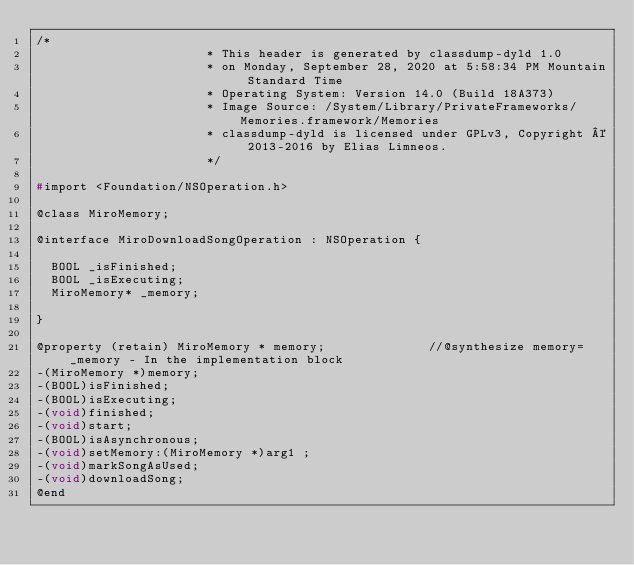<code> <loc_0><loc_0><loc_500><loc_500><_C_>/*
                       * This header is generated by classdump-dyld 1.0
                       * on Monday, September 28, 2020 at 5:58:34 PM Mountain Standard Time
                       * Operating System: Version 14.0 (Build 18A373)
                       * Image Source: /System/Library/PrivateFrameworks/Memories.framework/Memories
                       * classdump-dyld is licensed under GPLv3, Copyright © 2013-2016 by Elias Limneos.
                       */

#import <Foundation/NSOperation.h>

@class MiroMemory;

@interface MiroDownloadSongOperation : NSOperation {

	BOOL _isFinished;
	BOOL _isExecuting;
	MiroMemory* _memory;

}

@property (retain) MiroMemory * memory;              //@synthesize memory=_memory - In the implementation block
-(MiroMemory *)memory;
-(BOOL)isFinished;
-(BOOL)isExecuting;
-(void)finished;
-(void)start;
-(BOOL)isAsynchronous;
-(void)setMemory:(MiroMemory *)arg1 ;
-(void)markSongAsUsed;
-(void)downloadSong;
@end

</code> 